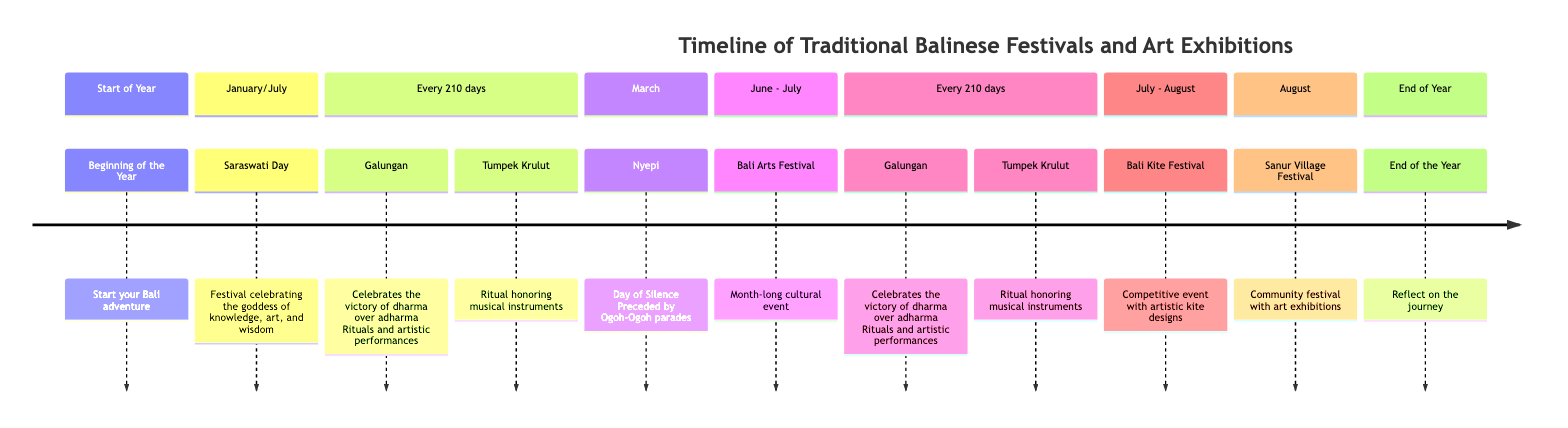What is the first festival listed in the timeline? The diagram starts with "Beginning of the Year" as the first entry in the "Start of Year" section, marking the beginning of the year and the start of a person’s adventure in Bali.
Answer: Beginning of the Year How often does Galungan occur? Galungan is listed under "Every 210 days," indicating that it takes place twice a year, every 210 days.
Answer: Every 210 days In which month does the Bali Arts Festival occur? The Bali Arts Festival is specifically noted to occur in the section spanning "June - July," indicating it lasts for a month during this period.
Answer: June - July What festival involves parades before a day of silence? The diagram mentions "Nyepi," which is marked as the "Day of Silence" that is preceded by Ogoh-Ogoh parades, making it clear that Nyepi is the festival involved.
Answer: Nyepi Which festival features artistic kite designs? The "Bali Kite Festival" is explicitly described as a “Competitive event with artistic kite designs,” which provides the answer to the question.
Answer: Bali Kite Festival What do the Sanur Village Festival and the Bali Arts Festival have in common? Both festivals are associated with community and cultural celebration; however, they have distinct features: the Sanur Village Festival includes “art exhibitions,” while the Bali Arts Festival is a “month-long cultural event.” Therefore, while they are similar in theme, they focus on different aspects.
Answer: Community celebration What is the significance of Tumpek Krulut in the timeline? Tumpek Krulut is defined as a ritual that honors musical instruments, reinforcing its cultural importance in conjunction with artistic expression within the Balinese traditions.
Answer: Honoring musical instruments What section of the timeline represents the end of the year? The timeline concludes with the section titled "End of the Year," which invites reflection on the journey experienced over the preceding months.
Answer: End of the Year 